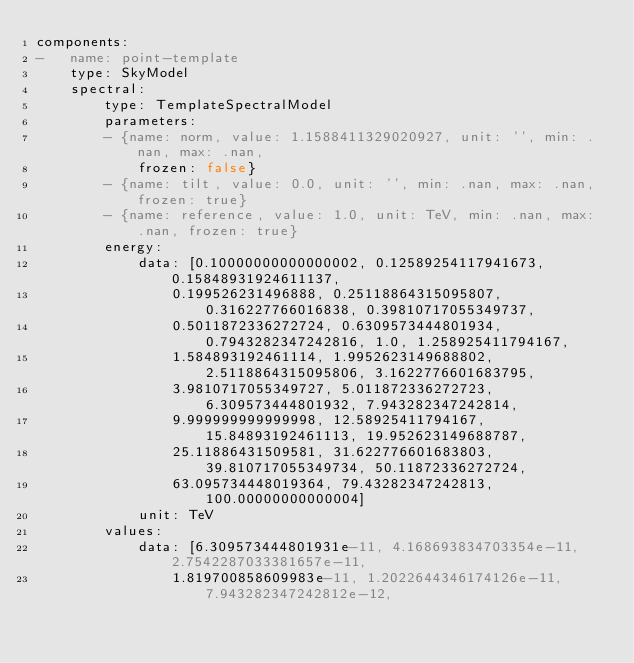Convert code to text. <code><loc_0><loc_0><loc_500><loc_500><_YAML_>components:
-   name: point-template
    type: SkyModel
    spectral:
        type: TemplateSpectralModel
        parameters:
        - {name: norm, value: 1.1588411329020927, unit: '', min: .nan, max: .nan,
            frozen: false}
        - {name: tilt, value: 0.0, unit: '', min: .nan, max: .nan, frozen: true}
        - {name: reference, value: 1.0, unit: TeV, min: .nan, max: .nan, frozen: true}
        energy:
            data: [0.10000000000000002, 0.12589254117941673, 0.15848931924611137,
                0.199526231496888, 0.25118864315095807, 0.316227766016838, 0.39810717055349737,
                0.5011872336272724, 0.6309573444801934, 0.7943282347242816, 1.0, 1.258925411794167,
                1.584893192461114, 1.9952623149688802, 2.5118864315095806, 3.1622776601683795,
                3.9810717055349727, 5.011872336272723, 6.309573444801932, 7.943282347242814,
                9.999999999999998, 12.58925411794167, 15.84893192461113, 19.952623149688787,
                25.11886431509581, 31.622776601683803, 39.810717055349734, 50.11872336272724,
                63.095734448019364, 79.43282347242813, 100.00000000000004]
            unit: TeV
        values:
            data: [6.309573444801931e-11, 4.168693834703354e-11, 2.7542287033381657e-11,
                1.819700858609983e-11, 1.2022644346174126e-11, 7.943282347242812e-12,</code> 